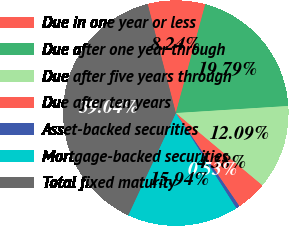Convert chart. <chart><loc_0><loc_0><loc_500><loc_500><pie_chart><fcel>Due in one year or less<fcel>Due after one year through<fcel>Due after five years through<fcel>Due after ten years<fcel>Asset-backed securities<fcel>Mortgage-backed securities<fcel>Total fixed maturity<nl><fcel>8.24%<fcel>19.79%<fcel>12.09%<fcel>4.38%<fcel>0.53%<fcel>15.94%<fcel>39.04%<nl></chart> 